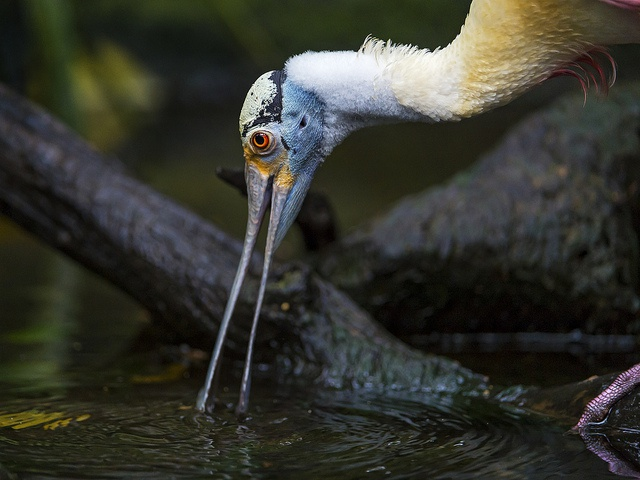Describe the objects in this image and their specific colors. I can see a bird in black, lightgray, gray, and darkgray tones in this image. 